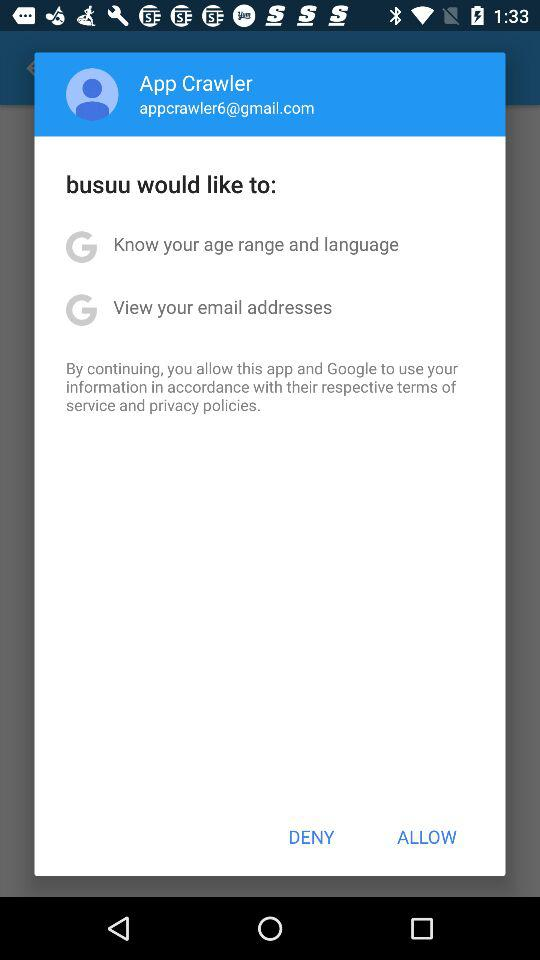What's the Gmail account? The Gmail account is appcrawler6@gmail.com. 